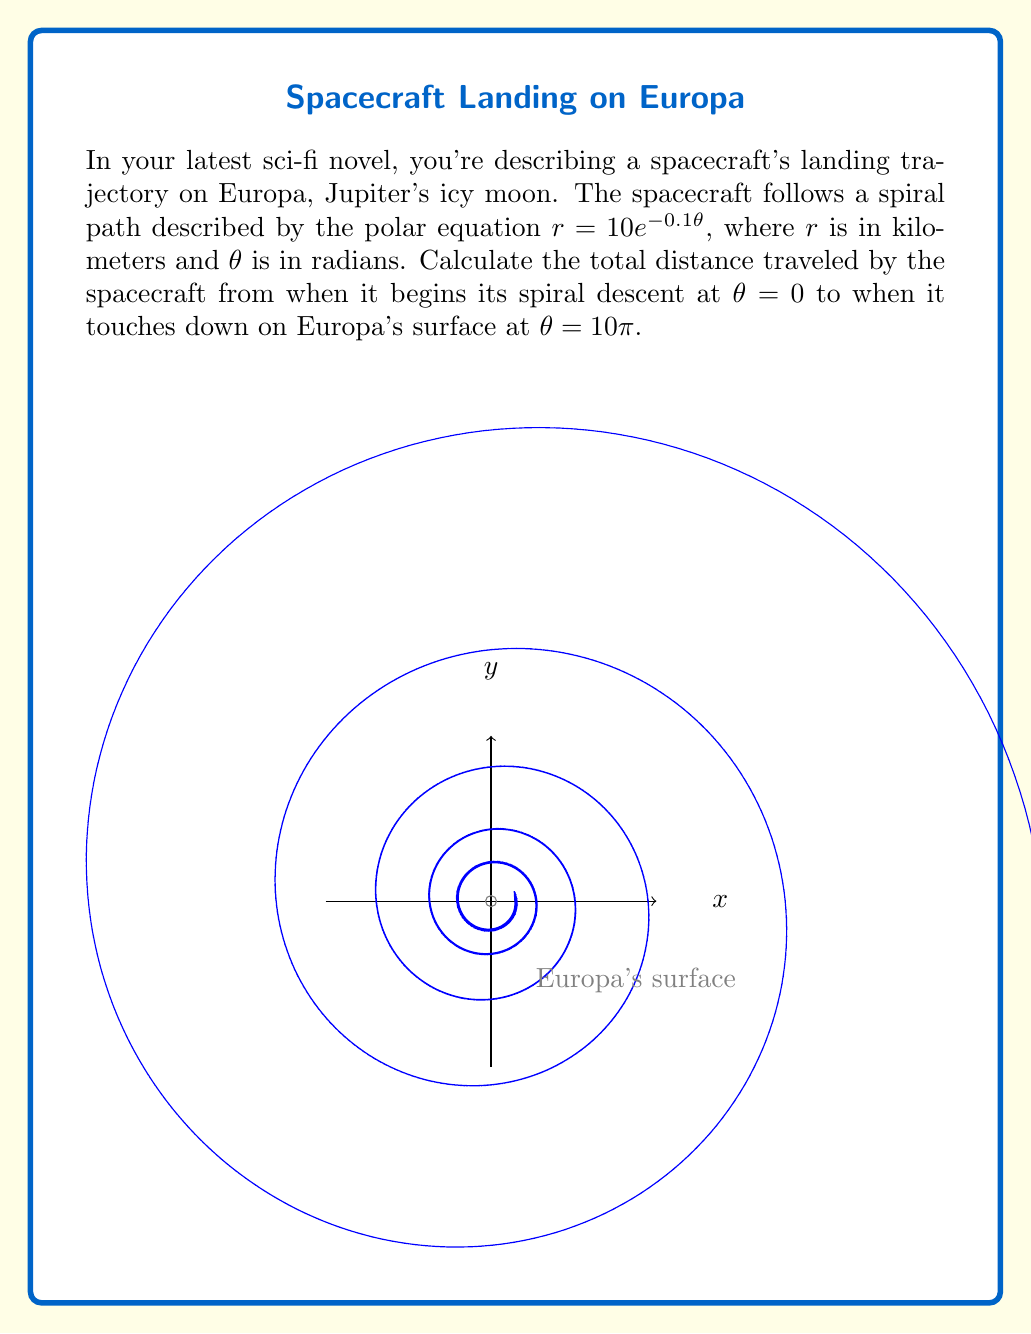Could you help me with this problem? Let's approach this step-by-step:

1) The length of a curve in polar coordinates is given by the formula:

   $$L = \int_a^b \sqrt{r^2 + \left(\frac{dr}{d\theta}\right)^2} d\theta$$

2) We need to find $\frac{dr}{d\theta}$. Given $r = 10e^{-0.1\theta}$:

   $$\frac{dr}{d\theta} = 10 \cdot (-0.1) \cdot e^{-0.1\theta} = -e^{-0.1\theta}$$

3) Now we can set up our integral:

   $$L = \int_0^{10\pi} \sqrt{(10e^{-0.1\theta})^2 + (-e^{-0.1\theta})^2} d\theta$$

4) Simplify under the square root:

   $$L = \int_0^{10\pi} \sqrt{100e^{-0.2\theta} + e^{-0.2\theta}} d\theta$$
   $$L = \int_0^{10\pi} \sqrt{101e^{-0.2\theta}} d\theta$$
   $$L = \int_0^{10\pi} \sqrt{101} \cdot e^{-0.1\theta} d\theta$$

5) Integrate:

   $$L = -10\sqrt{101} \cdot e^{-0.1\theta} \bigg|_0^{10\pi}$$

6) Evaluate the limits:

   $$L = -10\sqrt{101} \cdot (e^{-\pi} - 1)$$

7) Calculate the final value:

   $$L \approx 96.12 \text{ km}$$
Answer: $96.12$ km 